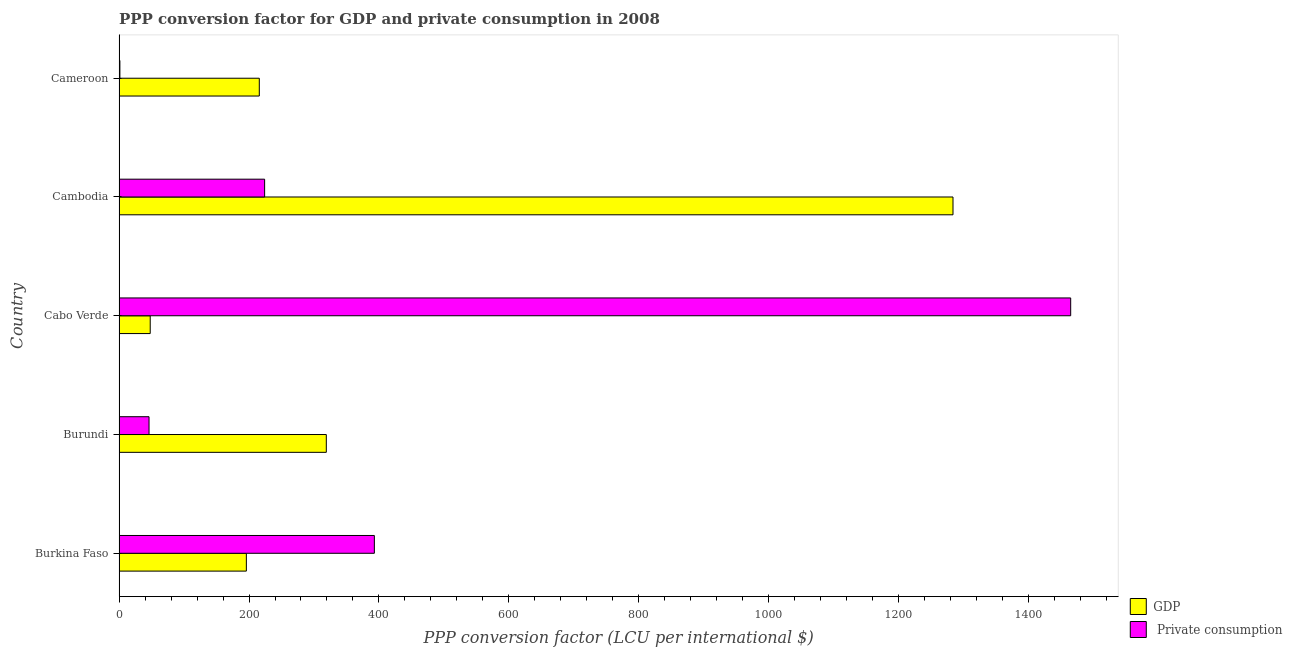How many groups of bars are there?
Offer a terse response. 5. Are the number of bars per tick equal to the number of legend labels?
Offer a terse response. Yes. Are the number of bars on each tick of the Y-axis equal?
Provide a succinct answer. Yes. What is the label of the 1st group of bars from the top?
Make the answer very short. Cameroon. What is the ppp conversion factor for private consumption in Burundi?
Provide a succinct answer. 46.14. Across all countries, what is the maximum ppp conversion factor for gdp?
Give a very brief answer. 1283.45. Across all countries, what is the minimum ppp conversion factor for gdp?
Ensure brevity in your answer.  47.97. In which country was the ppp conversion factor for private consumption maximum?
Your answer should be compact. Cabo Verde. In which country was the ppp conversion factor for private consumption minimum?
Your response must be concise. Cameroon. What is the total ppp conversion factor for gdp in the graph?
Provide a short and direct response. 2062.18. What is the difference between the ppp conversion factor for gdp in Burundi and that in Cabo Verde?
Offer a terse response. 271.01. What is the difference between the ppp conversion factor for private consumption in Cameroon and the ppp conversion factor for gdp in Burkina Faso?
Your answer should be compact. -194.63. What is the average ppp conversion factor for gdp per country?
Your response must be concise. 412.44. What is the difference between the ppp conversion factor for private consumption and ppp conversion factor for gdp in Burkina Faso?
Provide a succinct answer. 196.98. In how many countries, is the ppp conversion factor for gdp greater than 800 LCU?
Keep it short and to the point. 1. What is the ratio of the ppp conversion factor for private consumption in Cabo Verde to that in Cameroon?
Your answer should be compact. 1124.97. What is the difference between the highest and the second highest ppp conversion factor for private consumption?
Ensure brevity in your answer.  1071.67. What is the difference between the highest and the lowest ppp conversion factor for private consumption?
Provide a succinct answer. 1463.28. Is the sum of the ppp conversion factor for private consumption in Burundi and Cabo Verde greater than the maximum ppp conversion factor for gdp across all countries?
Make the answer very short. Yes. What does the 1st bar from the top in Cambodia represents?
Provide a succinct answer.  Private consumption. What does the 2nd bar from the bottom in Cambodia represents?
Give a very brief answer.  Private consumption. How many bars are there?
Give a very brief answer. 10. How many legend labels are there?
Provide a succinct answer. 2. What is the title of the graph?
Provide a short and direct response. PPP conversion factor for GDP and private consumption in 2008. What is the label or title of the X-axis?
Provide a succinct answer. PPP conversion factor (LCU per international $). What is the PPP conversion factor (LCU per international $) of GDP in Burkina Faso?
Your response must be concise. 195.93. What is the PPP conversion factor (LCU per international $) of  Private consumption in Burkina Faso?
Keep it short and to the point. 392.91. What is the PPP conversion factor (LCU per international $) of GDP in Burundi?
Your response must be concise. 318.99. What is the PPP conversion factor (LCU per international $) of  Private consumption in Burundi?
Offer a terse response. 46.14. What is the PPP conversion factor (LCU per international $) of GDP in Cabo Verde?
Give a very brief answer. 47.97. What is the PPP conversion factor (LCU per international $) in  Private consumption in Cabo Verde?
Keep it short and to the point. 1464.58. What is the PPP conversion factor (LCU per international $) in GDP in Cambodia?
Provide a succinct answer. 1283.45. What is the PPP conversion factor (LCU per international $) in  Private consumption in Cambodia?
Your answer should be compact. 224.05. What is the PPP conversion factor (LCU per international $) in GDP in Cameroon?
Your answer should be very brief. 215.84. What is the PPP conversion factor (LCU per international $) in  Private consumption in Cameroon?
Your response must be concise. 1.3. Across all countries, what is the maximum PPP conversion factor (LCU per international $) in GDP?
Your answer should be very brief. 1283.45. Across all countries, what is the maximum PPP conversion factor (LCU per international $) of  Private consumption?
Your answer should be very brief. 1464.58. Across all countries, what is the minimum PPP conversion factor (LCU per international $) of GDP?
Offer a terse response. 47.97. Across all countries, what is the minimum PPP conversion factor (LCU per international $) of  Private consumption?
Give a very brief answer. 1.3. What is the total PPP conversion factor (LCU per international $) of GDP in the graph?
Offer a very short reply. 2062.18. What is the total PPP conversion factor (LCU per international $) of  Private consumption in the graph?
Offer a terse response. 2128.99. What is the difference between the PPP conversion factor (LCU per international $) of GDP in Burkina Faso and that in Burundi?
Ensure brevity in your answer.  -123.06. What is the difference between the PPP conversion factor (LCU per international $) of  Private consumption in Burkina Faso and that in Burundi?
Provide a short and direct response. 346.77. What is the difference between the PPP conversion factor (LCU per international $) in GDP in Burkina Faso and that in Cabo Verde?
Your response must be concise. 147.96. What is the difference between the PPP conversion factor (LCU per international $) of  Private consumption in Burkina Faso and that in Cabo Verde?
Ensure brevity in your answer.  -1071.67. What is the difference between the PPP conversion factor (LCU per international $) of GDP in Burkina Faso and that in Cambodia?
Give a very brief answer. -1087.52. What is the difference between the PPP conversion factor (LCU per international $) in  Private consumption in Burkina Faso and that in Cambodia?
Provide a short and direct response. 168.86. What is the difference between the PPP conversion factor (LCU per international $) in GDP in Burkina Faso and that in Cameroon?
Make the answer very short. -19.91. What is the difference between the PPP conversion factor (LCU per international $) in  Private consumption in Burkina Faso and that in Cameroon?
Offer a terse response. 391.61. What is the difference between the PPP conversion factor (LCU per international $) of GDP in Burundi and that in Cabo Verde?
Your response must be concise. 271.01. What is the difference between the PPP conversion factor (LCU per international $) in  Private consumption in Burundi and that in Cabo Verde?
Make the answer very short. -1418.44. What is the difference between the PPP conversion factor (LCU per international $) in GDP in Burundi and that in Cambodia?
Offer a very short reply. -964.47. What is the difference between the PPP conversion factor (LCU per international $) in  Private consumption in Burundi and that in Cambodia?
Keep it short and to the point. -177.91. What is the difference between the PPP conversion factor (LCU per international $) of GDP in Burundi and that in Cameroon?
Make the answer very short. 103.15. What is the difference between the PPP conversion factor (LCU per international $) of  Private consumption in Burundi and that in Cameroon?
Provide a succinct answer. 44.84. What is the difference between the PPP conversion factor (LCU per international $) of GDP in Cabo Verde and that in Cambodia?
Your response must be concise. -1235.48. What is the difference between the PPP conversion factor (LCU per international $) in  Private consumption in Cabo Verde and that in Cambodia?
Your answer should be very brief. 1240.53. What is the difference between the PPP conversion factor (LCU per international $) of GDP in Cabo Verde and that in Cameroon?
Keep it short and to the point. -167.87. What is the difference between the PPP conversion factor (LCU per international $) of  Private consumption in Cabo Verde and that in Cameroon?
Offer a terse response. 1463.28. What is the difference between the PPP conversion factor (LCU per international $) of GDP in Cambodia and that in Cameroon?
Offer a terse response. 1067.62. What is the difference between the PPP conversion factor (LCU per international $) in  Private consumption in Cambodia and that in Cameroon?
Ensure brevity in your answer.  222.75. What is the difference between the PPP conversion factor (LCU per international $) of GDP in Burkina Faso and the PPP conversion factor (LCU per international $) of  Private consumption in Burundi?
Give a very brief answer. 149.79. What is the difference between the PPP conversion factor (LCU per international $) of GDP in Burkina Faso and the PPP conversion factor (LCU per international $) of  Private consumption in Cabo Verde?
Your answer should be very brief. -1268.65. What is the difference between the PPP conversion factor (LCU per international $) of GDP in Burkina Faso and the PPP conversion factor (LCU per international $) of  Private consumption in Cambodia?
Give a very brief answer. -28.12. What is the difference between the PPP conversion factor (LCU per international $) of GDP in Burkina Faso and the PPP conversion factor (LCU per international $) of  Private consumption in Cameroon?
Make the answer very short. 194.63. What is the difference between the PPP conversion factor (LCU per international $) in GDP in Burundi and the PPP conversion factor (LCU per international $) in  Private consumption in Cabo Verde?
Give a very brief answer. -1145.59. What is the difference between the PPP conversion factor (LCU per international $) in GDP in Burundi and the PPP conversion factor (LCU per international $) in  Private consumption in Cambodia?
Your answer should be compact. 94.94. What is the difference between the PPP conversion factor (LCU per international $) of GDP in Burundi and the PPP conversion factor (LCU per international $) of  Private consumption in Cameroon?
Offer a terse response. 317.68. What is the difference between the PPP conversion factor (LCU per international $) of GDP in Cabo Verde and the PPP conversion factor (LCU per international $) of  Private consumption in Cambodia?
Your response must be concise. -176.08. What is the difference between the PPP conversion factor (LCU per international $) in GDP in Cabo Verde and the PPP conversion factor (LCU per international $) in  Private consumption in Cameroon?
Make the answer very short. 46.67. What is the difference between the PPP conversion factor (LCU per international $) of GDP in Cambodia and the PPP conversion factor (LCU per international $) of  Private consumption in Cameroon?
Offer a very short reply. 1282.15. What is the average PPP conversion factor (LCU per international $) of GDP per country?
Give a very brief answer. 412.44. What is the average PPP conversion factor (LCU per international $) of  Private consumption per country?
Provide a succinct answer. 425.8. What is the difference between the PPP conversion factor (LCU per international $) of GDP and PPP conversion factor (LCU per international $) of  Private consumption in Burkina Faso?
Provide a succinct answer. -196.98. What is the difference between the PPP conversion factor (LCU per international $) of GDP and PPP conversion factor (LCU per international $) of  Private consumption in Burundi?
Offer a very short reply. 272.84. What is the difference between the PPP conversion factor (LCU per international $) of GDP and PPP conversion factor (LCU per international $) of  Private consumption in Cabo Verde?
Your answer should be very brief. -1416.61. What is the difference between the PPP conversion factor (LCU per international $) of GDP and PPP conversion factor (LCU per international $) of  Private consumption in Cambodia?
Your answer should be very brief. 1059.4. What is the difference between the PPP conversion factor (LCU per international $) of GDP and PPP conversion factor (LCU per international $) of  Private consumption in Cameroon?
Keep it short and to the point. 214.54. What is the ratio of the PPP conversion factor (LCU per international $) of GDP in Burkina Faso to that in Burundi?
Give a very brief answer. 0.61. What is the ratio of the PPP conversion factor (LCU per international $) in  Private consumption in Burkina Faso to that in Burundi?
Keep it short and to the point. 8.51. What is the ratio of the PPP conversion factor (LCU per international $) in GDP in Burkina Faso to that in Cabo Verde?
Your answer should be very brief. 4.08. What is the ratio of the PPP conversion factor (LCU per international $) of  Private consumption in Burkina Faso to that in Cabo Verde?
Your answer should be very brief. 0.27. What is the ratio of the PPP conversion factor (LCU per international $) of GDP in Burkina Faso to that in Cambodia?
Make the answer very short. 0.15. What is the ratio of the PPP conversion factor (LCU per international $) of  Private consumption in Burkina Faso to that in Cambodia?
Make the answer very short. 1.75. What is the ratio of the PPP conversion factor (LCU per international $) of GDP in Burkina Faso to that in Cameroon?
Ensure brevity in your answer.  0.91. What is the ratio of the PPP conversion factor (LCU per international $) of  Private consumption in Burkina Faso to that in Cameroon?
Your response must be concise. 301.8. What is the ratio of the PPP conversion factor (LCU per international $) of GDP in Burundi to that in Cabo Verde?
Make the answer very short. 6.65. What is the ratio of the PPP conversion factor (LCU per international $) of  Private consumption in Burundi to that in Cabo Verde?
Make the answer very short. 0.03. What is the ratio of the PPP conversion factor (LCU per international $) of GDP in Burundi to that in Cambodia?
Your response must be concise. 0.25. What is the ratio of the PPP conversion factor (LCU per international $) of  Private consumption in Burundi to that in Cambodia?
Make the answer very short. 0.21. What is the ratio of the PPP conversion factor (LCU per international $) of GDP in Burundi to that in Cameroon?
Ensure brevity in your answer.  1.48. What is the ratio of the PPP conversion factor (LCU per international $) of  Private consumption in Burundi to that in Cameroon?
Give a very brief answer. 35.44. What is the ratio of the PPP conversion factor (LCU per international $) of GDP in Cabo Verde to that in Cambodia?
Provide a short and direct response. 0.04. What is the ratio of the PPP conversion factor (LCU per international $) of  Private consumption in Cabo Verde to that in Cambodia?
Give a very brief answer. 6.54. What is the ratio of the PPP conversion factor (LCU per international $) in GDP in Cabo Verde to that in Cameroon?
Provide a short and direct response. 0.22. What is the ratio of the PPP conversion factor (LCU per international $) of  Private consumption in Cabo Verde to that in Cameroon?
Your answer should be compact. 1124.97. What is the ratio of the PPP conversion factor (LCU per international $) of GDP in Cambodia to that in Cameroon?
Your answer should be very brief. 5.95. What is the ratio of the PPP conversion factor (LCU per international $) in  Private consumption in Cambodia to that in Cameroon?
Provide a succinct answer. 172.1. What is the difference between the highest and the second highest PPP conversion factor (LCU per international $) of GDP?
Ensure brevity in your answer.  964.47. What is the difference between the highest and the second highest PPP conversion factor (LCU per international $) in  Private consumption?
Offer a very short reply. 1071.67. What is the difference between the highest and the lowest PPP conversion factor (LCU per international $) of GDP?
Make the answer very short. 1235.48. What is the difference between the highest and the lowest PPP conversion factor (LCU per international $) in  Private consumption?
Make the answer very short. 1463.28. 